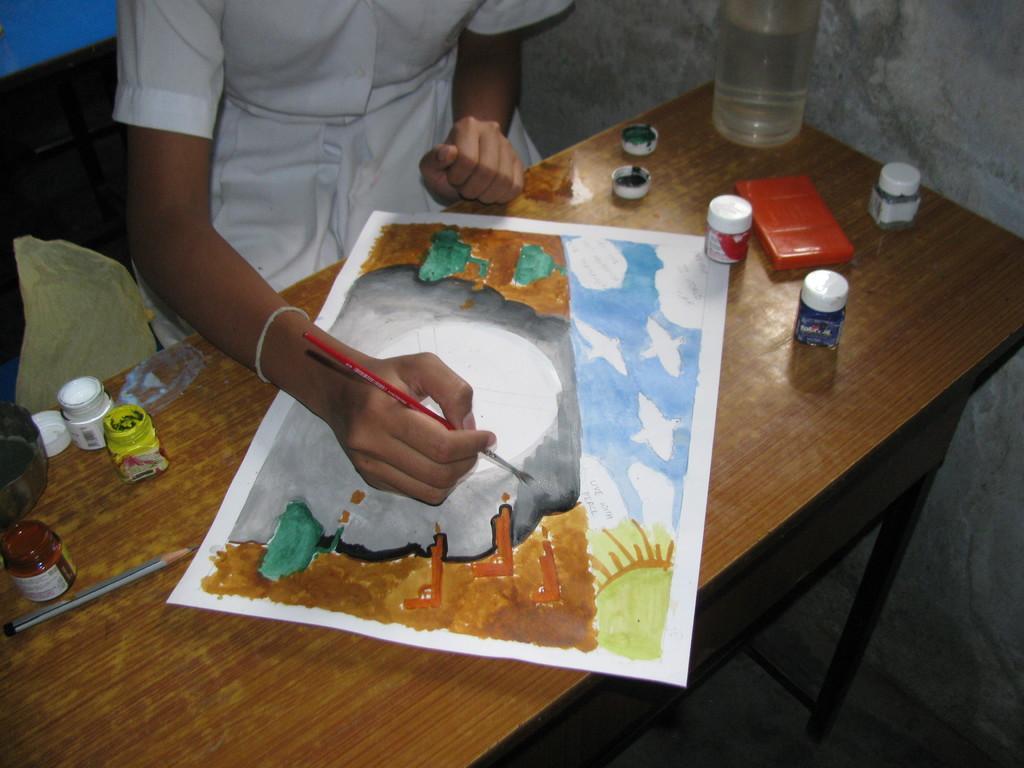Can you describe this image briefly? In this picture there is a girl at the top side of the image and there is a bench in front of her, on which she is painting and there are paint bottles on the bench. 